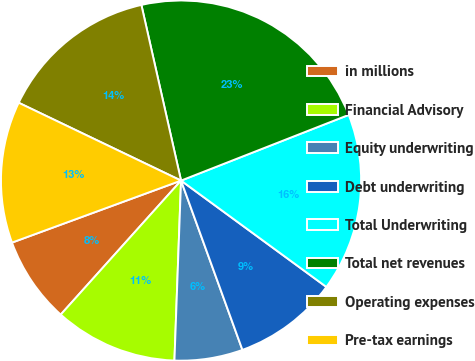<chart> <loc_0><loc_0><loc_500><loc_500><pie_chart><fcel>in millions<fcel>Financial Advisory<fcel>Equity underwriting<fcel>Debt underwriting<fcel>Total Underwriting<fcel>Total net revenues<fcel>Operating expenses<fcel>Pre-tax earnings<nl><fcel>7.76%<fcel>11.06%<fcel>6.12%<fcel>9.41%<fcel>16.0%<fcel>22.59%<fcel>14.35%<fcel>12.71%<nl></chart> 